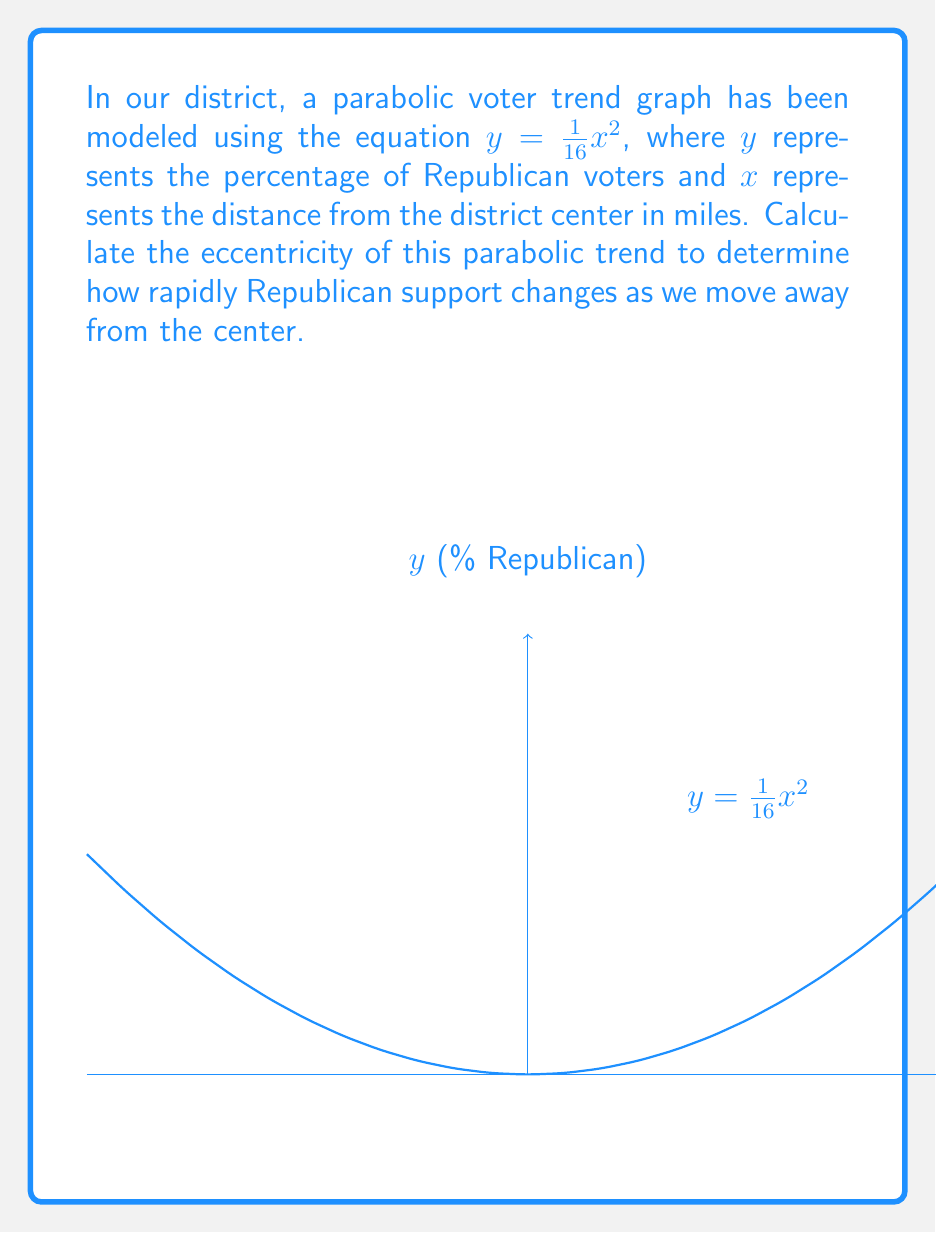Can you answer this question? To find the eccentricity of a parabola, we can use the following steps:

1) The general form of a parabola is $y = \frac{1}{4p}x^2$, where $p$ is the distance from the vertex to the focus.

2) In our equation $y = \frac{1}{16}x^2$, we can see that $\frac{1}{4p} = \frac{1}{16}$

3) Solving for $p$:
   $\frac{1}{4p} = \frac{1}{16}$
   $4p = 16$
   $p = 4$

4) The eccentricity ($e$) of a parabola is always 1. This can be derived from the general formula for conic sections:

   $e = \sqrt{1 + \frac{b^2}{a^2}}$

   where for a parabola, $\frac{b^2}{a^2}$ approaches 0, leaving $e = \sqrt{1} = 1$

5) Therefore, the eccentricity of this parabolic voter trend is 1.

This eccentricity of 1 indicates that the rate of change in Republican support is constant as we move away from the district center, which is characteristic of all parabolas.
Answer: 1 